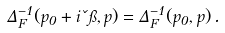Convert formula to latex. <formula><loc_0><loc_0><loc_500><loc_500>\Delta _ { F } ^ { - 1 } ( p _ { 0 } + i \kappa \pi , { p } ) = \Delta _ { F } ^ { - 1 } ( p _ { 0 } , { p } ) \, .</formula> 